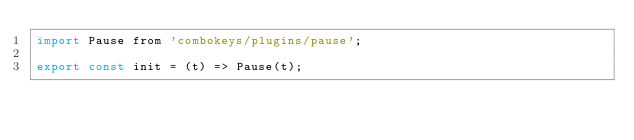Convert code to text. <code><loc_0><loc_0><loc_500><loc_500><_JavaScript_>import Pause from 'combokeys/plugins/pause';

export const init = (t) => Pause(t);
</code> 